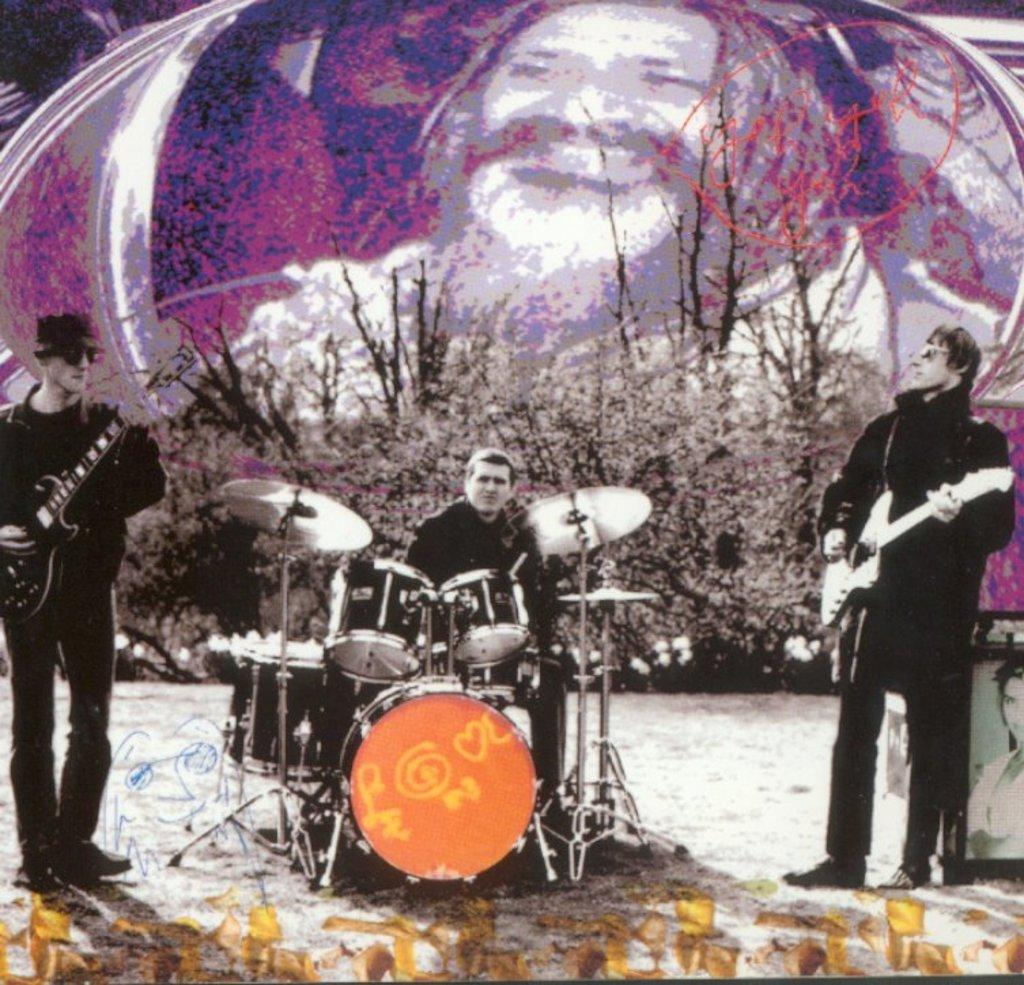What is the person in the image doing? There is a person sitting and playing a musical instrument in the image. How many other people are playing musical instruments in the image? There are two other persons standing and playing a guitar in the image. What can be seen in the image besides the people playing musical instruments? There are plants in the image. Is there any artwork or decoration visible in the image? Yes, there is a picture on a wall in the image. What type of reaction can be seen from the eggs in the image? There are no eggs present in the image, so it is not possible to determine any reaction from them. 